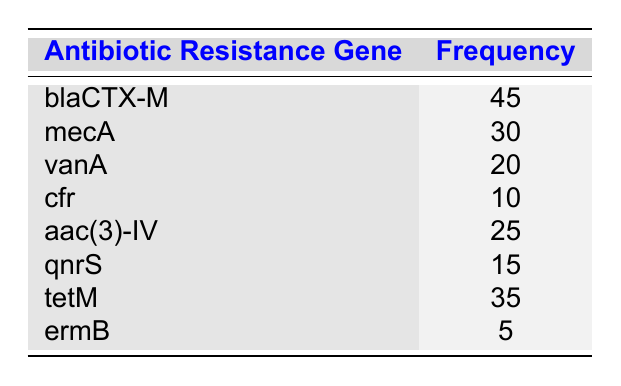What is the frequency of the gene blaCTX-M? The table lists the frequency of the gene blaCTX-M as 45.
Answer: 45 How many antibiotic resistance genes are listed in the table? By counting the number of rows in the table, we see there are 8 antibiotic resistance genes listed.
Answer: 8 Which gene has the highest frequency? Looking through the frequency values, blaCTX-M has the highest frequency of 45.
Answer: blaCTX-M What is the sum of frequencies for the genes aac(3)-IV and tetM? The frequency of aac(3)-IV is 25 and the frequency of tetM is 35. Adding these together gives 25 + 35 = 60.
Answer: 60 Is the frequency of the gene ermB greater than the gene vanA? The frequency of ermB is 5, and the frequency of vanA is 20. Since 5 is not greater than 20, the answer is no.
Answer: No What is the average frequency of all genes in the table? To find the average, first sum all frequencies: 45 + 30 + 20 + 10 + 25 + 15 + 35 + 5 = 185. Then divide by the number of genes which is 8: 185 / 8 = 23.125.
Answer: 23.125 Which two genes have frequencies that, when combined, exceed 50? We need to identify combinations of frequencies. For instance, blaCTX-M (45) and mecA (30) sum to 75, and tetM (35) with aac(3)-IV (25) sums to 60. Both these combinations exceed 50.
Answer: blaCTX-M and mecA; tetM and aac(3)-IV How many genes have a frequency of less than 15? The frequencies below 15 are for cfr (10) and ermB (5), giving a total of 2 genes.
Answer: 2 